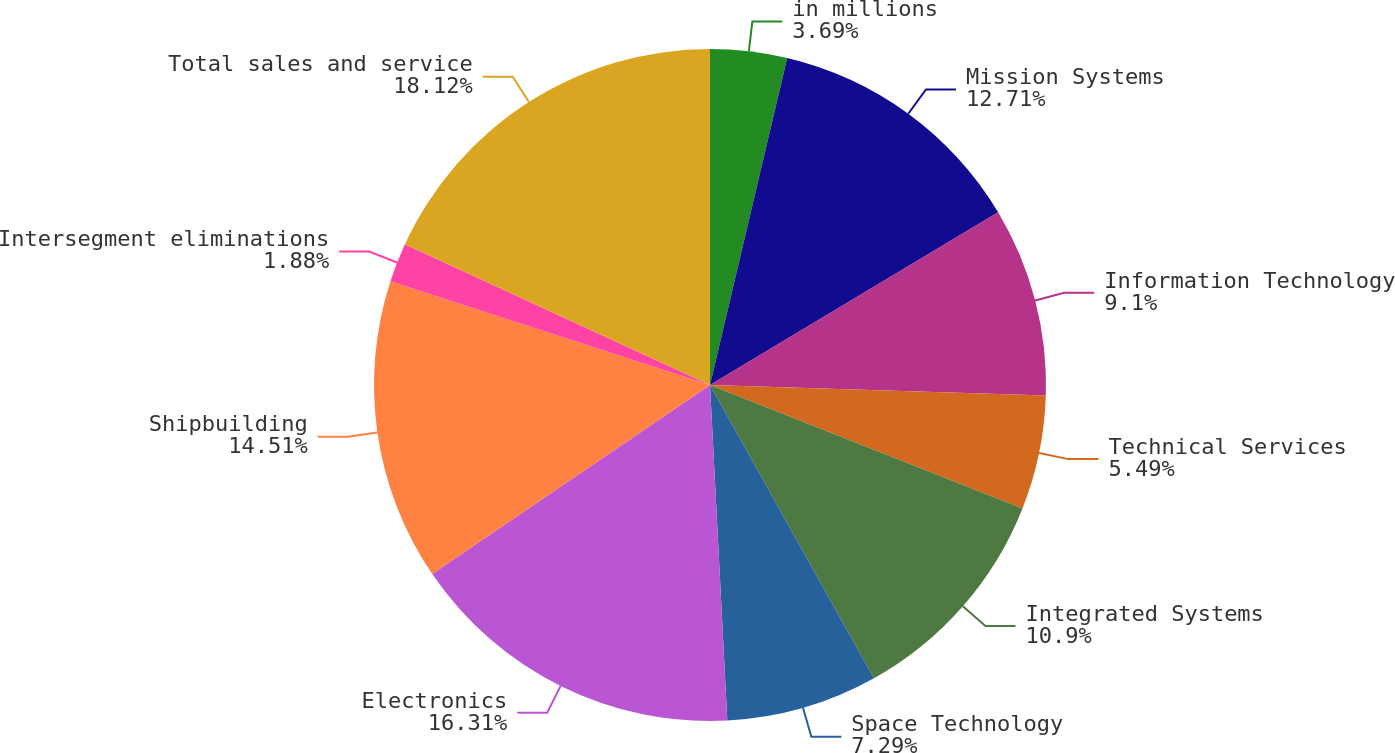<chart> <loc_0><loc_0><loc_500><loc_500><pie_chart><fcel>in millions<fcel>Mission Systems<fcel>Information Technology<fcel>Technical Services<fcel>Integrated Systems<fcel>Space Technology<fcel>Electronics<fcel>Shipbuilding<fcel>Intersegment eliminations<fcel>Total sales and service<nl><fcel>3.69%<fcel>12.71%<fcel>9.1%<fcel>5.49%<fcel>10.9%<fcel>7.29%<fcel>16.31%<fcel>14.51%<fcel>1.88%<fcel>18.12%<nl></chart> 